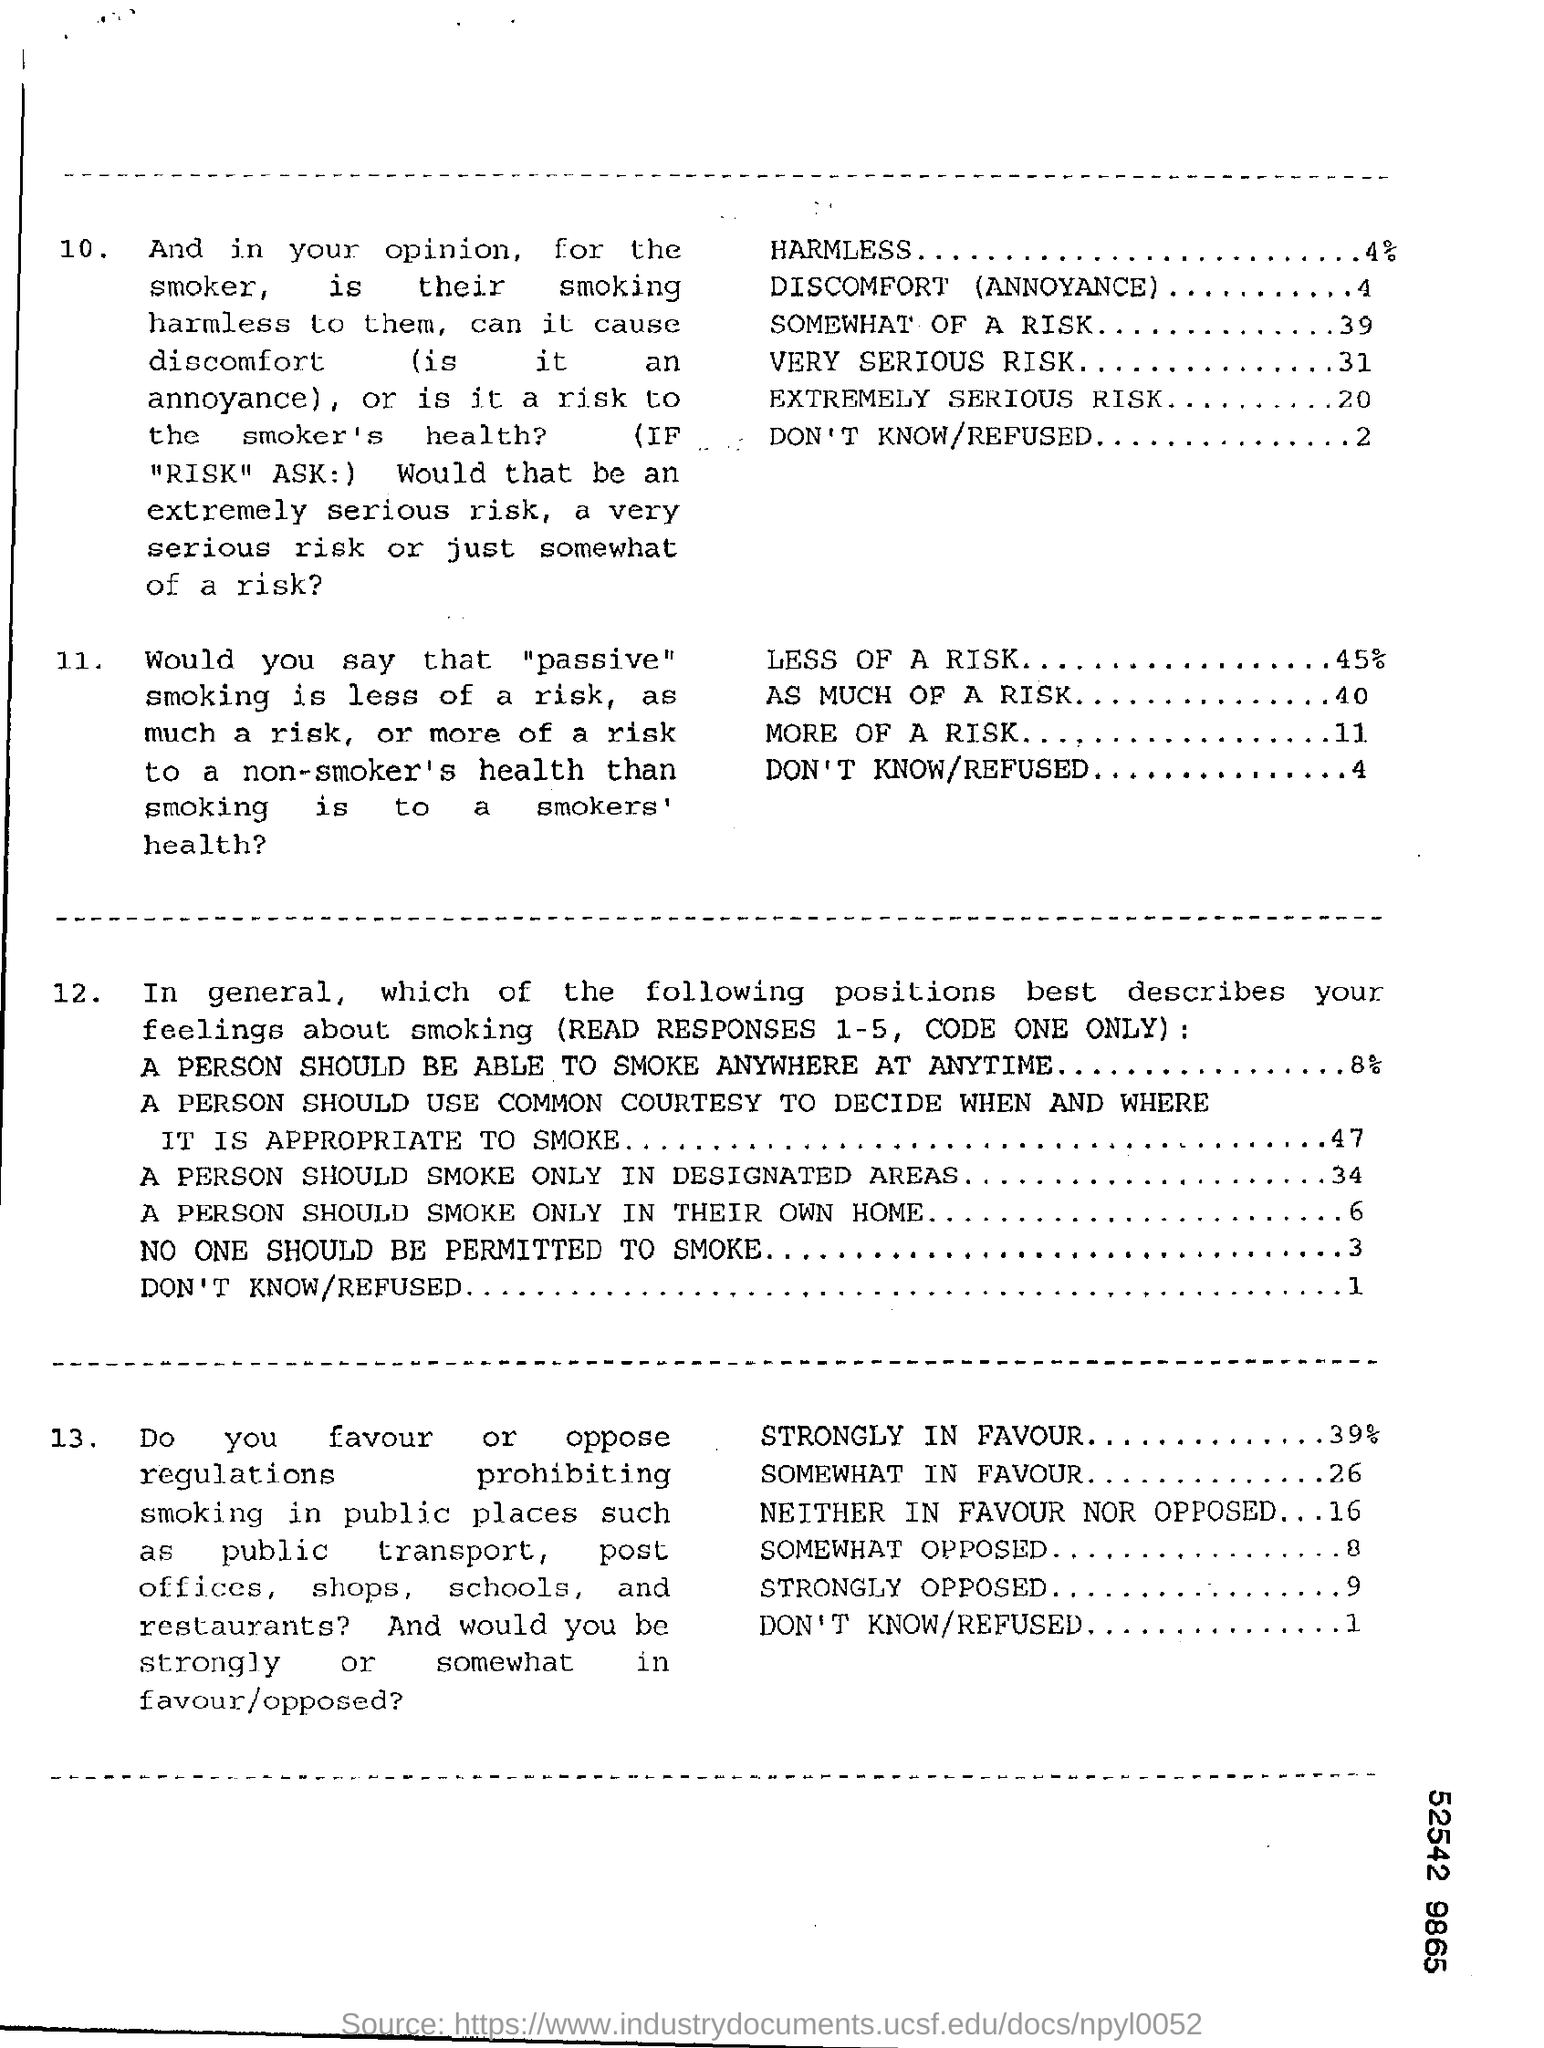Highlight a few significant elements in this photo. The percentage for "Less of a Risk" is 45%. The value for 'Somewhat Opposed' is 8. According to the given scale, the value for 'Strongly Opposed' is 9. The percentage for the word "Harmless" is 4%. According to the data, 39% of respondents strongly favored the proposal. 